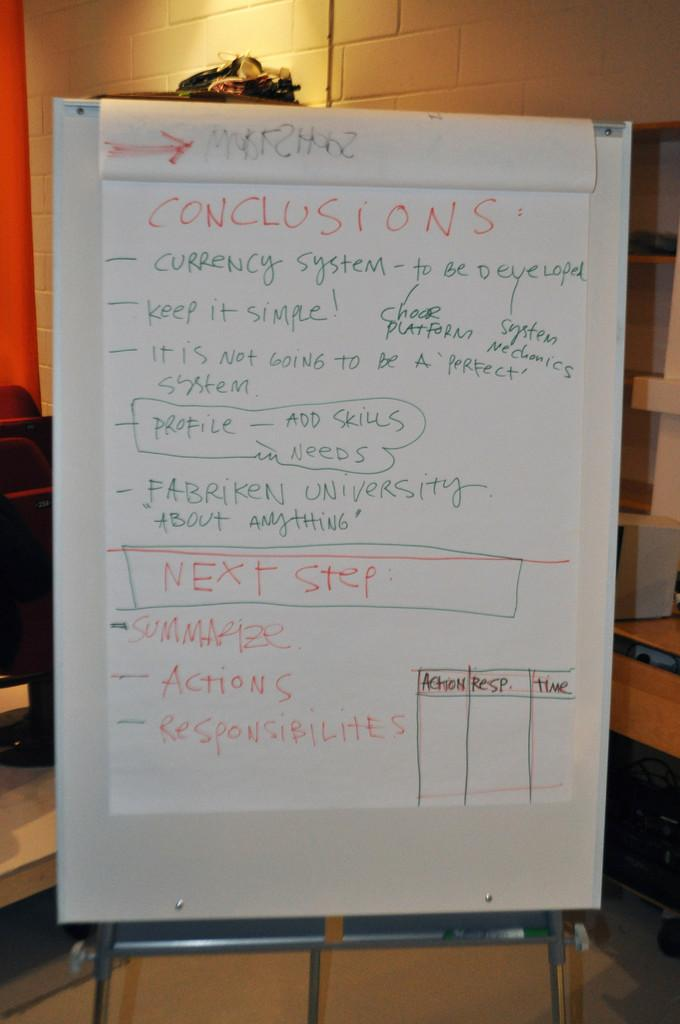<image>
Summarize the visual content of the image. The easel is holding a white large white paper with conclusions written on it. 